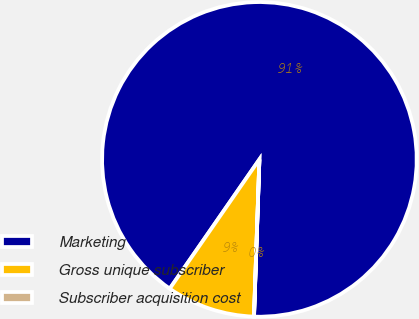Convert chart to OTSL. <chart><loc_0><loc_0><loc_500><loc_500><pie_chart><fcel>Marketing<fcel>Gross unique subscriber<fcel>Subscriber acquisition cost<nl><fcel>90.9%<fcel>9.1%<fcel>0.01%<nl></chart> 